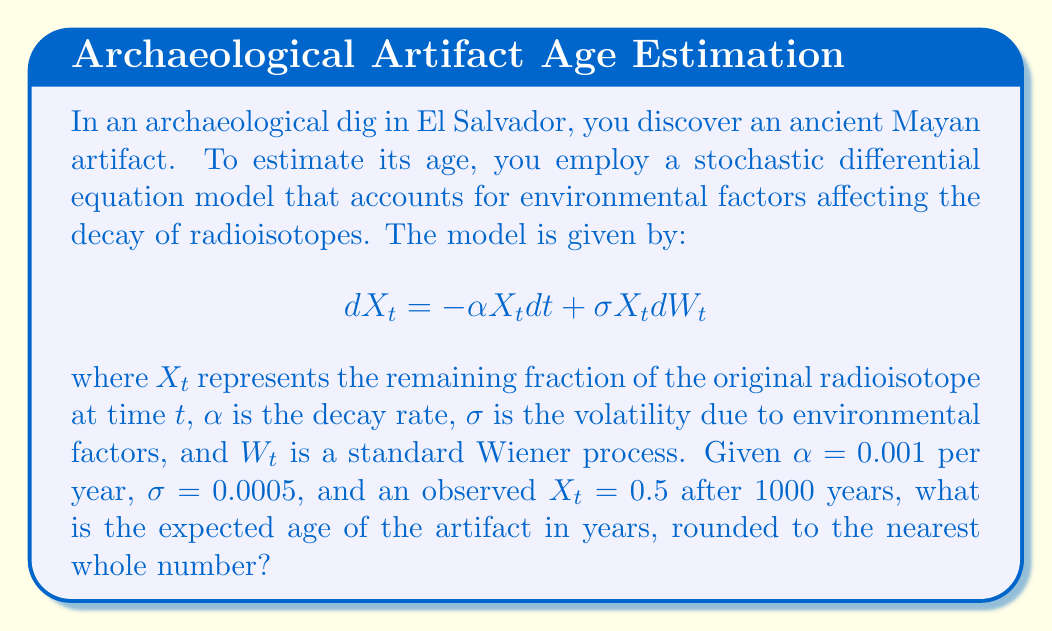Provide a solution to this math problem. To solve this problem, we'll follow these steps:

1) The solution to the stochastic differential equation is given by the geometric Brownian motion:

   $$X_t = X_0 \exp\left(\left(\alpha - \frac{\sigma^2}{2}\right)t + \sigma W_t\right)$$

2) Taking the expectation of both sides:

   $$E[X_t] = X_0 \exp\left(\left(\alpha - \frac{\sigma^2}{2}\right)t\right)$$

3) We're given that $E[X_t] = 0.5$ after 1000 years. Let's substitute the known values:

   $$0.5 = 1 \cdot \exp\left(\left(0.001 - \frac{0.0005^2}{2}\right) \cdot 1000\right)$$

4) Taking the natural logarithm of both sides:

   $$\ln(0.5) = \left(0.001 - \frac{0.0005^2}{2}\right) \cdot 1000$$

5) Simplify:

   $$-0.69315 = (0.001 - 0.000000125) \cdot 1000 = 0.999875 \cdot 1000$$

6) Divide both sides by 0.999875:

   $$\frac{-0.69315}{0.999875} = 1000$$

7) To find the age of the artifact, we need to solve for $t$ in the equation:

   $$0.5 = \exp\left(0.999875t \cdot \frac{-0.69315}{1000}\right)$$

8) Taking the natural logarithm of both sides:

   $$\ln(0.5) = 0.999875t \cdot \frac{-0.69315}{1000}$$

9) Solve for $t$:

   $$t = \frac{\ln(0.5)}{0.999875 \cdot \frac{-0.69315}{1000}} = 693.4721$$

10) Rounding to the nearest whole number:

    $$t \approx 693$$

Therefore, the expected age of the artifact is approximately 693 years.
Answer: 693 years 